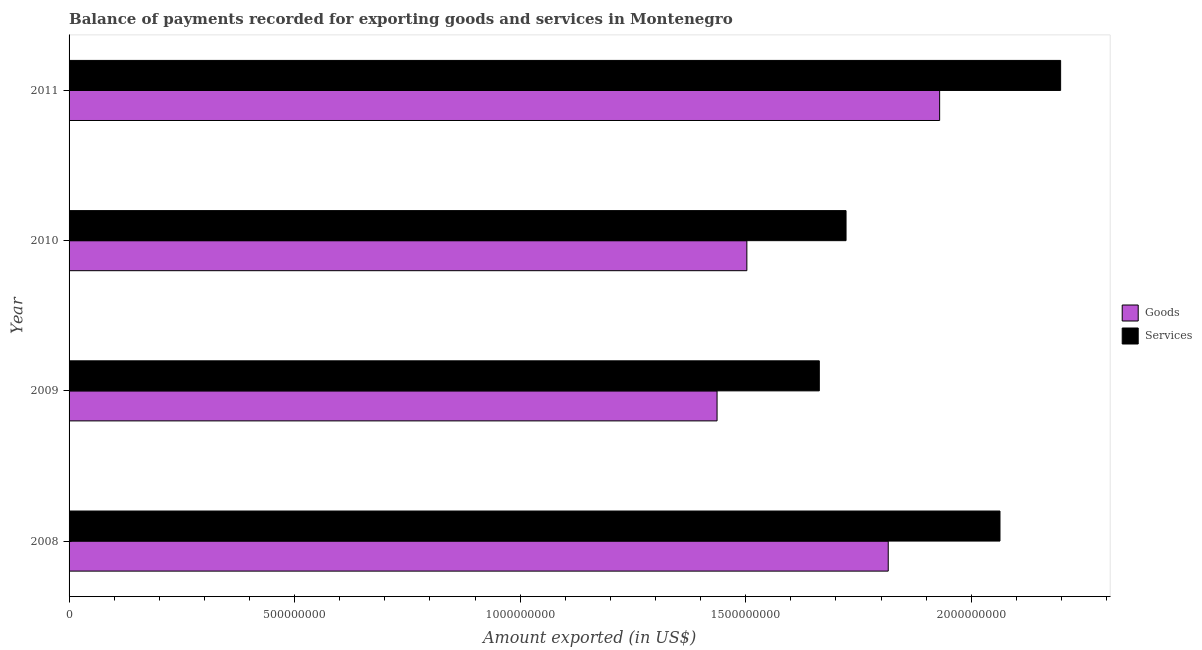How many different coloured bars are there?
Ensure brevity in your answer.  2. Are the number of bars on each tick of the Y-axis equal?
Offer a terse response. Yes. How many bars are there on the 4th tick from the top?
Give a very brief answer. 2. In how many cases, is the number of bars for a given year not equal to the number of legend labels?
Your response must be concise. 0. What is the amount of goods exported in 2011?
Give a very brief answer. 1.93e+09. Across all years, what is the maximum amount of services exported?
Your response must be concise. 2.20e+09. Across all years, what is the minimum amount of goods exported?
Provide a succinct answer. 1.44e+09. In which year was the amount of goods exported maximum?
Keep it short and to the point. 2011. In which year was the amount of services exported minimum?
Provide a succinct answer. 2009. What is the total amount of services exported in the graph?
Offer a very short reply. 7.65e+09. What is the difference between the amount of services exported in 2009 and that in 2010?
Provide a short and direct response. -5.93e+07. What is the difference between the amount of services exported in 2008 and the amount of goods exported in 2011?
Offer a terse response. 1.34e+08. What is the average amount of services exported per year?
Your response must be concise. 1.91e+09. In the year 2009, what is the difference between the amount of goods exported and amount of services exported?
Your answer should be compact. -2.27e+08. In how many years, is the amount of goods exported greater than 1800000000 US$?
Provide a short and direct response. 2. What is the ratio of the amount of services exported in 2010 to that in 2011?
Offer a terse response. 0.78. What is the difference between the highest and the second highest amount of services exported?
Ensure brevity in your answer.  1.34e+08. What is the difference between the highest and the lowest amount of goods exported?
Make the answer very short. 4.93e+08. In how many years, is the amount of goods exported greater than the average amount of goods exported taken over all years?
Provide a short and direct response. 2. What does the 2nd bar from the top in 2009 represents?
Offer a very short reply. Goods. What does the 2nd bar from the bottom in 2010 represents?
Provide a short and direct response. Services. Are all the bars in the graph horizontal?
Your answer should be very brief. Yes. Does the graph contain grids?
Offer a very short reply. No. What is the title of the graph?
Your response must be concise. Balance of payments recorded for exporting goods and services in Montenegro. What is the label or title of the X-axis?
Your response must be concise. Amount exported (in US$). What is the label or title of the Y-axis?
Your response must be concise. Year. What is the Amount exported (in US$) of Goods in 2008?
Provide a succinct answer. 1.82e+09. What is the Amount exported (in US$) in Services in 2008?
Give a very brief answer. 2.06e+09. What is the Amount exported (in US$) in Goods in 2009?
Provide a short and direct response. 1.44e+09. What is the Amount exported (in US$) in Services in 2009?
Give a very brief answer. 1.66e+09. What is the Amount exported (in US$) of Goods in 2010?
Offer a terse response. 1.50e+09. What is the Amount exported (in US$) of Services in 2010?
Your answer should be very brief. 1.72e+09. What is the Amount exported (in US$) in Goods in 2011?
Offer a very short reply. 1.93e+09. What is the Amount exported (in US$) of Services in 2011?
Offer a terse response. 2.20e+09. Across all years, what is the maximum Amount exported (in US$) of Goods?
Offer a very short reply. 1.93e+09. Across all years, what is the maximum Amount exported (in US$) of Services?
Keep it short and to the point. 2.20e+09. Across all years, what is the minimum Amount exported (in US$) of Goods?
Your answer should be very brief. 1.44e+09. Across all years, what is the minimum Amount exported (in US$) in Services?
Your answer should be very brief. 1.66e+09. What is the total Amount exported (in US$) in Goods in the graph?
Provide a succinct answer. 6.68e+09. What is the total Amount exported (in US$) in Services in the graph?
Give a very brief answer. 7.65e+09. What is the difference between the Amount exported (in US$) in Goods in 2008 and that in 2009?
Keep it short and to the point. 3.79e+08. What is the difference between the Amount exported (in US$) of Services in 2008 and that in 2009?
Ensure brevity in your answer.  4.01e+08. What is the difference between the Amount exported (in US$) of Goods in 2008 and that in 2010?
Offer a terse response. 3.13e+08. What is the difference between the Amount exported (in US$) of Services in 2008 and that in 2010?
Make the answer very short. 3.41e+08. What is the difference between the Amount exported (in US$) in Goods in 2008 and that in 2011?
Your answer should be very brief. -1.14e+08. What is the difference between the Amount exported (in US$) of Services in 2008 and that in 2011?
Your answer should be compact. -1.34e+08. What is the difference between the Amount exported (in US$) in Goods in 2009 and that in 2010?
Your answer should be very brief. -6.61e+07. What is the difference between the Amount exported (in US$) of Services in 2009 and that in 2010?
Your answer should be compact. -5.93e+07. What is the difference between the Amount exported (in US$) in Goods in 2009 and that in 2011?
Keep it short and to the point. -4.93e+08. What is the difference between the Amount exported (in US$) of Services in 2009 and that in 2011?
Make the answer very short. -5.35e+08. What is the difference between the Amount exported (in US$) of Goods in 2010 and that in 2011?
Give a very brief answer. -4.27e+08. What is the difference between the Amount exported (in US$) of Services in 2010 and that in 2011?
Keep it short and to the point. -4.76e+08. What is the difference between the Amount exported (in US$) in Goods in 2008 and the Amount exported (in US$) in Services in 2009?
Your response must be concise. 1.53e+08. What is the difference between the Amount exported (in US$) in Goods in 2008 and the Amount exported (in US$) in Services in 2010?
Your answer should be compact. 9.35e+07. What is the difference between the Amount exported (in US$) in Goods in 2008 and the Amount exported (in US$) in Services in 2011?
Provide a short and direct response. -3.82e+08. What is the difference between the Amount exported (in US$) of Goods in 2009 and the Amount exported (in US$) of Services in 2010?
Make the answer very short. -2.86e+08. What is the difference between the Amount exported (in US$) in Goods in 2009 and the Amount exported (in US$) in Services in 2011?
Ensure brevity in your answer.  -7.62e+08. What is the difference between the Amount exported (in US$) in Goods in 2010 and the Amount exported (in US$) in Services in 2011?
Provide a succinct answer. -6.96e+08. What is the average Amount exported (in US$) in Goods per year?
Keep it short and to the point. 1.67e+09. What is the average Amount exported (in US$) in Services per year?
Your answer should be very brief. 1.91e+09. In the year 2008, what is the difference between the Amount exported (in US$) of Goods and Amount exported (in US$) of Services?
Keep it short and to the point. -2.48e+08. In the year 2009, what is the difference between the Amount exported (in US$) of Goods and Amount exported (in US$) of Services?
Your answer should be compact. -2.27e+08. In the year 2010, what is the difference between the Amount exported (in US$) of Goods and Amount exported (in US$) of Services?
Your answer should be compact. -2.20e+08. In the year 2011, what is the difference between the Amount exported (in US$) in Goods and Amount exported (in US$) in Services?
Offer a terse response. -2.68e+08. What is the ratio of the Amount exported (in US$) of Goods in 2008 to that in 2009?
Your answer should be very brief. 1.26. What is the ratio of the Amount exported (in US$) of Services in 2008 to that in 2009?
Your answer should be compact. 1.24. What is the ratio of the Amount exported (in US$) in Goods in 2008 to that in 2010?
Provide a succinct answer. 1.21. What is the ratio of the Amount exported (in US$) of Services in 2008 to that in 2010?
Your answer should be very brief. 1.2. What is the ratio of the Amount exported (in US$) of Goods in 2008 to that in 2011?
Keep it short and to the point. 0.94. What is the ratio of the Amount exported (in US$) of Services in 2008 to that in 2011?
Your answer should be very brief. 0.94. What is the ratio of the Amount exported (in US$) in Goods in 2009 to that in 2010?
Provide a short and direct response. 0.96. What is the ratio of the Amount exported (in US$) in Services in 2009 to that in 2010?
Give a very brief answer. 0.97. What is the ratio of the Amount exported (in US$) of Goods in 2009 to that in 2011?
Ensure brevity in your answer.  0.74. What is the ratio of the Amount exported (in US$) of Services in 2009 to that in 2011?
Your response must be concise. 0.76. What is the ratio of the Amount exported (in US$) of Goods in 2010 to that in 2011?
Offer a very short reply. 0.78. What is the ratio of the Amount exported (in US$) in Services in 2010 to that in 2011?
Your answer should be compact. 0.78. What is the difference between the highest and the second highest Amount exported (in US$) of Goods?
Offer a very short reply. 1.14e+08. What is the difference between the highest and the second highest Amount exported (in US$) of Services?
Provide a succinct answer. 1.34e+08. What is the difference between the highest and the lowest Amount exported (in US$) of Goods?
Provide a succinct answer. 4.93e+08. What is the difference between the highest and the lowest Amount exported (in US$) of Services?
Your response must be concise. 5.35e+08. 